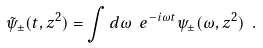<formula> <loc_0><loc_0><loc_500><loc_500>\tilde { \psi } _ { \pm } ( t , z ^ { 2 } ) = \int d \omega \ e ^ { - i \omega t } \psi _ { \pm } ( \omega , z ^ { 2 } ) \ .</formula> 